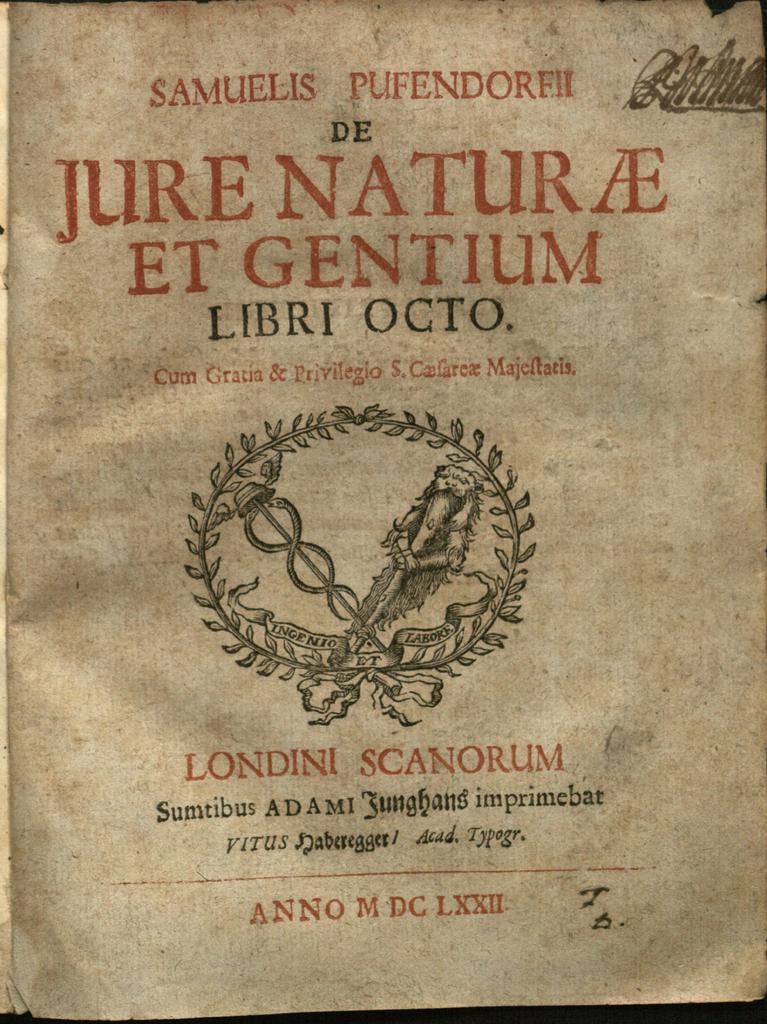Who wrote the book?
Provide a short and direct response. Samuelis pufendorfii. What is the book's title?
Your answer should be compact. Jure naturae et gentium. 